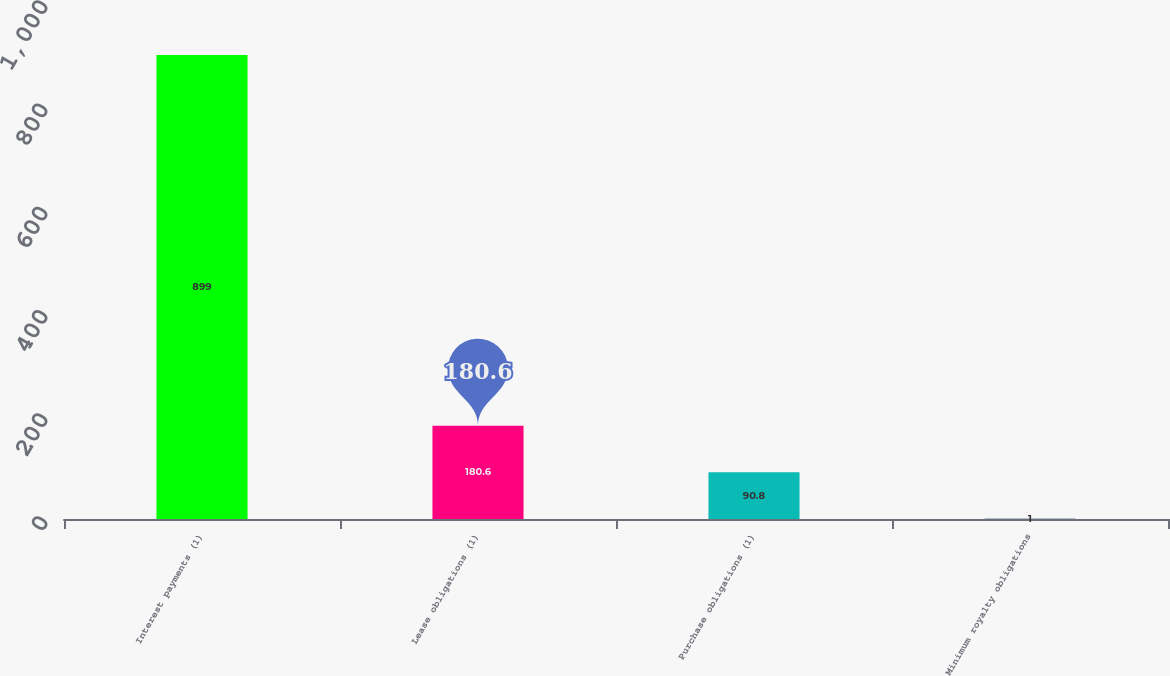Convert chart to OTSL. <chart><loc_0><loc_0><loc_500><loc_500><bar_chart><fcel>Interest payments (1)<fcel>Lease obligations (1)<fcel>Purchase obligations (1)<fcel>Minimum royalty obligations<nl><fcel>899<fcel>180.6<fcel>90.8<fcel>1<nl></chart> 